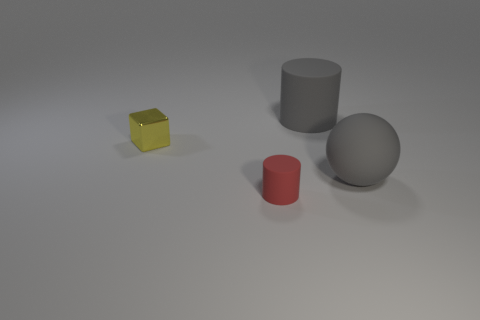Subtract all red cylinders. Subtract all red spheres. How many cylinders are left? 1 Add 4 gray cubes. How many objects exist? 8 Subtract all spheres. How many objects are left? 3 Add 4 big matte things. How many big matte things exist? 6 Subtract 1 gray cylinders. How many objects are left? 3 Subtract all large green cylinders. Subtract all yellow blocks. How many objects are left? 3 Add 3 small red objects. How many small red objects are left? 4 